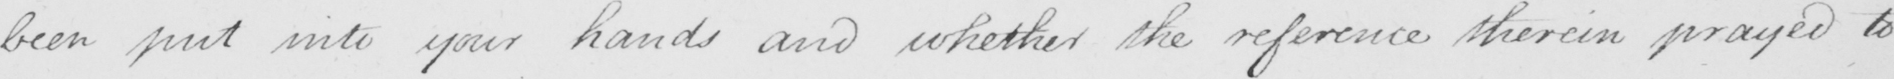What does this handwritten line say? been put into your hands and whether the reference therein prayed to 